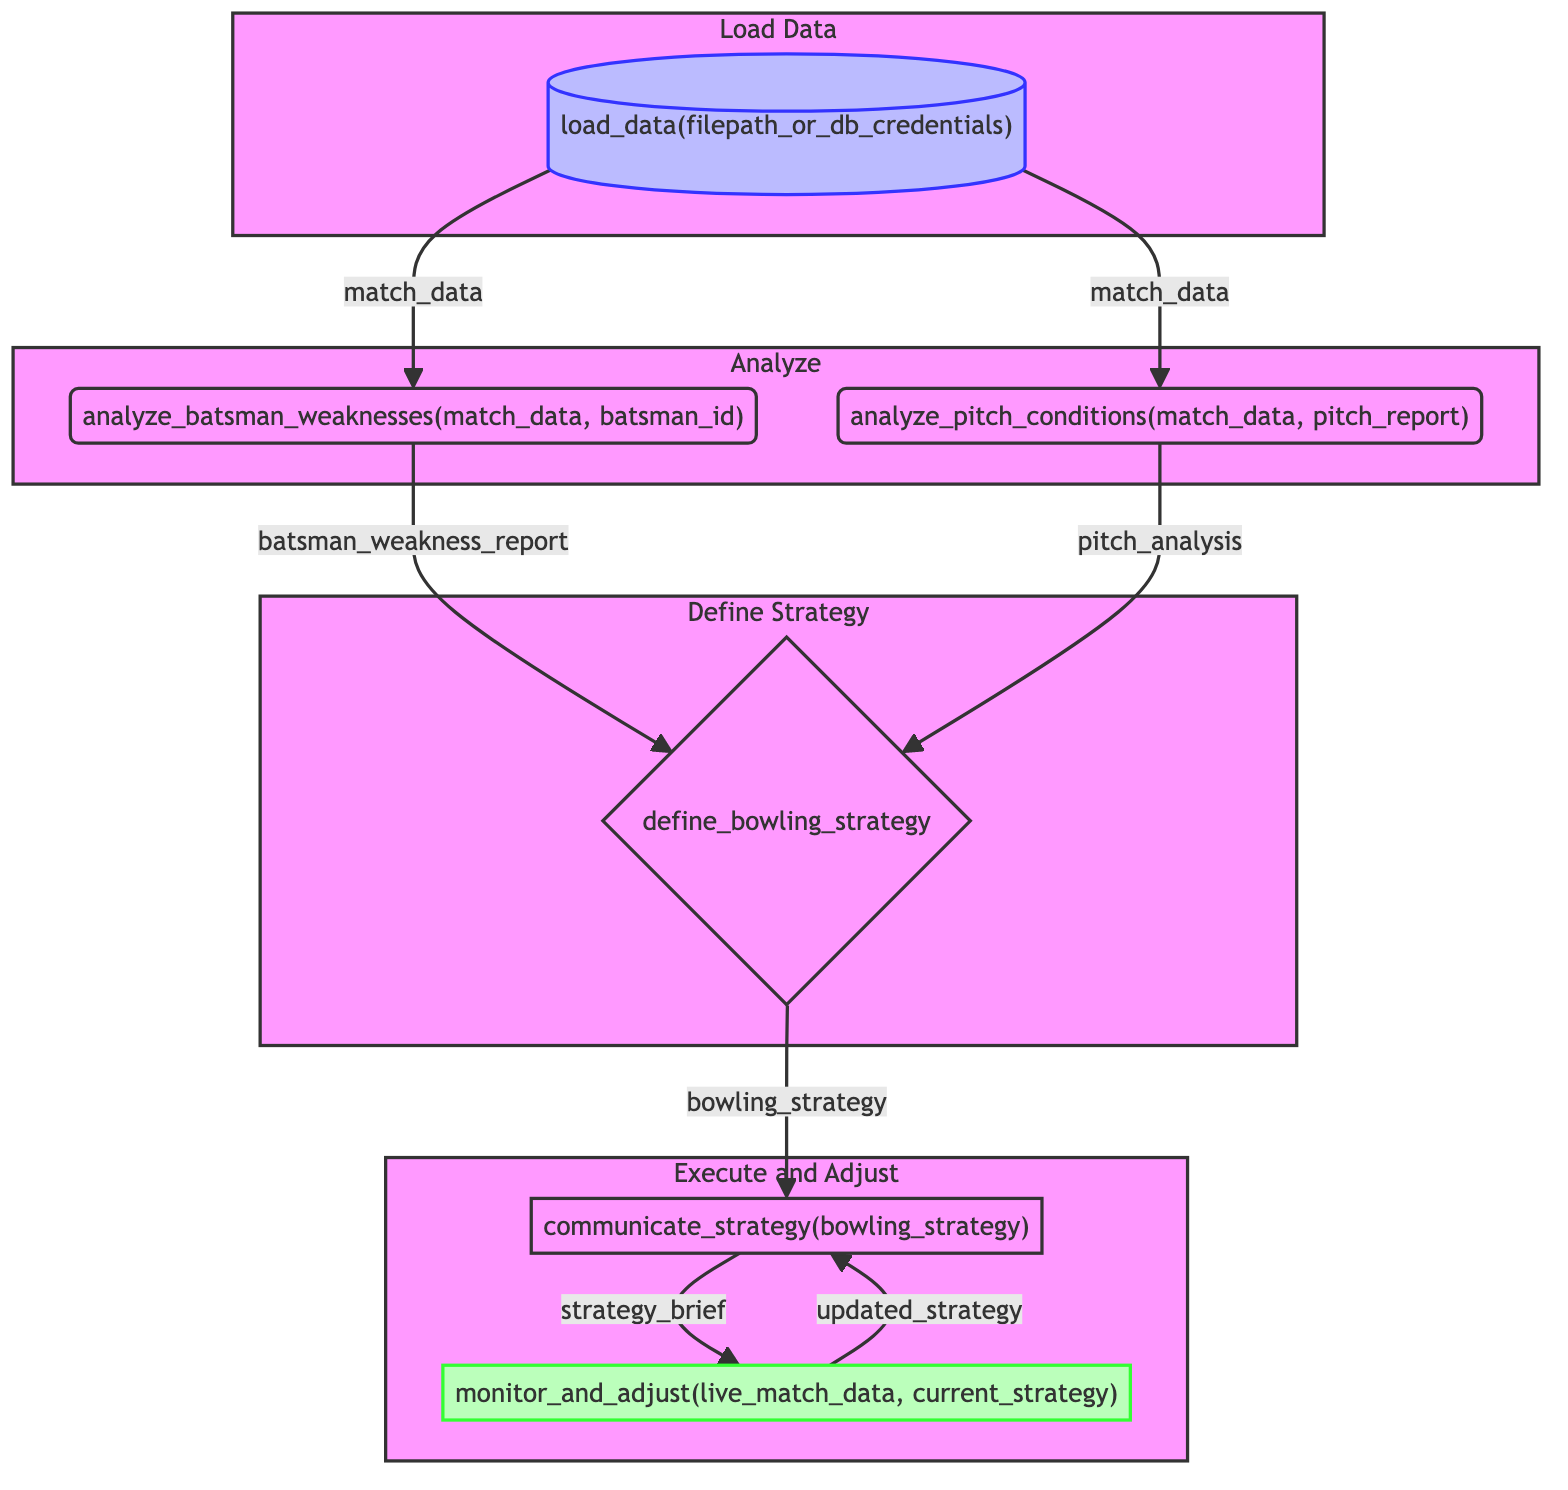what is the first step in the flowchart? The first step, labeled "load_data", involves loading historical match data using a specified filepath or database credentials. This initializes the process.
Answer: load_data how many main steps are present in the diagram? By counting the labeled steps, there are six main steps in the diagram, from loading data to monitoring and adjusting tactics.
Answer: six what information do we input into the "analyze_pitch_conditions" node? The input for "analyze_pitch_conditions" consists of match data and a pitch report, which are crucial for evaluating the nature of the pitch.
Answer: match_data, pitch_report which node directly follows the "define_bowling_strategy" step? The node that follows "define_bowling_strategy" is "communicate_strategy", where the computed strategy is conveyed to the bowler.
Answer: communicate_strategy what is the outcome of the "monitor_and_adjust" step? The outcome of the "monitor_and_adjust" step is the "updated_strategy", which reflects any adjustments made based on live match data and the current strategy.
Answer: updated_strategy what two analyses are combined in the "define_bowling_strategy"? The "define_bowling_strategy" combines the analyses from "analyze_batsman_weaknesses" and "analyze_pitch_conditions" to form a comprehensive bowling strategy.
Answer: batsman_weakness_report, pitch_analysis which step requires batsman ID as input? The step that requires batsman ID as input is "analyze_batsman_weaknesses", which focuses on identifying the weaknesses of the opposing batsmen based on individual performance.
Answer: analyze_batsman_weaknesses how does the flow from "communicate_strategy" return to itself? The flow returns from "monitor_and_adjust" to "communicate_strategy" in a loop, indicating that the strategy is continuously updated and communicated as the match progresses.
Answer: updated_strategy what is the purpose of the "analyze_batsman_weaknesses" step? The purpose of "analyze_batsman_weaknesses" is to identify the weaknesses of opposing batsmen, which assists in formulating effective bowling tactics.
Answer: analyze weaknesses of opposing batsmen 